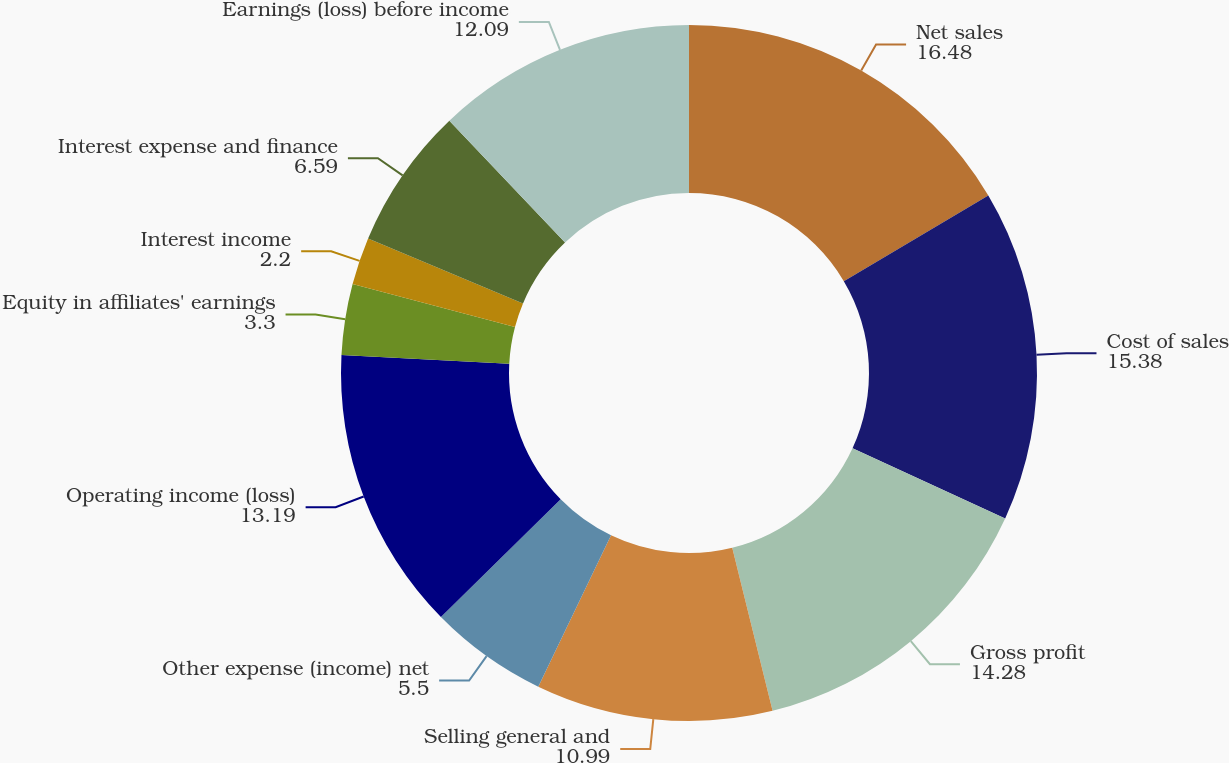Convert chart to OTSL. <chart><loc_0><loc_0><loc_500><loc_500><pie_chart><fcel>Net sales<fcel>Cost of sales<fcel>Gross profit<fcel>Selling general and<fcel>Other expense (income) net<fcel>Operating income (loss)<fcel>Equity in affiliates' earnings<fcel>Interest income<fcel>Interest expense and finance<fcel>Earnings (loss) before income<nl><fcel>16.48%<fcel>15.38%<fcel>14.28%<fcel>10.99%<fcel>5.5%<fcel>13.19%<fcel>3.3%<fcel>2.2%<fcel>6.59%<fcel>12.09%<nl></chart> 